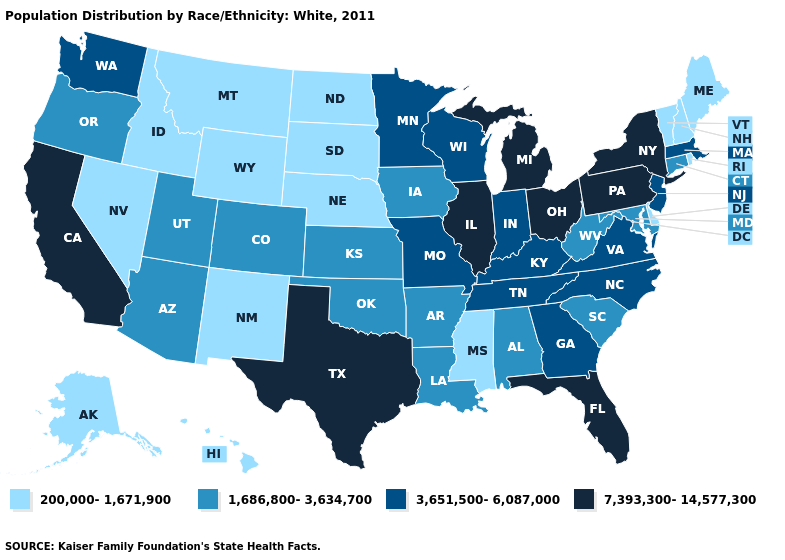Name the states that have a value in the range 7,393,300-14,577,300?
Write a very short answer. California, Florida, Illinois, Michigan, New York, Ohio, Pennsylvania, Texas. What is the value of New Jersey?
Give a very brief answer. 3,651,500-6,087,000. What is the value of Idaho?
Quick response, please. 200,000-1,671,900. Does the map have missing data?
Give a very brief answer. No. What is the value of Virginia?
Quick response, please. 3,651,500-6,087,000. Does Georgia have the highest value in the South?
Give a very brief answer. No. What is the value of Kansas?
Short answer required. 1,686,800-3,634,700. Among the states that border Connecticut , does Massachusetts have the lowest value?
Keep it brief. No. Does New Mexico have the lowest value in the USA?
Be succinct. Yes. Does the first symbol in the legend represent the smallest category?
Keep it brief. Yes. Does the first symbol in the legend represent the smallest category?
Write a very short answer. Yes. Among the states that border South Dakota , which have the lowest value?
Write a very short answer. Montana, Nebraska, North Dakota, Wyoming. What is the highest value in the West ?
Give a very brief answer. 7,393,300-14,577,300. What is the highest value in the Northeast ?
Answer briefly. 7,393,300-14,577,300. Name the states that have a value in the range 1,686,800-3,634,700?
Be succinct. Alabama, Arizona, Arkansas, Colorado, Connecticut, Iowa, Kansas, Louisiana, Maryland, Oklahoma, Oregon, South Carolina, Utah, West Virginia. 